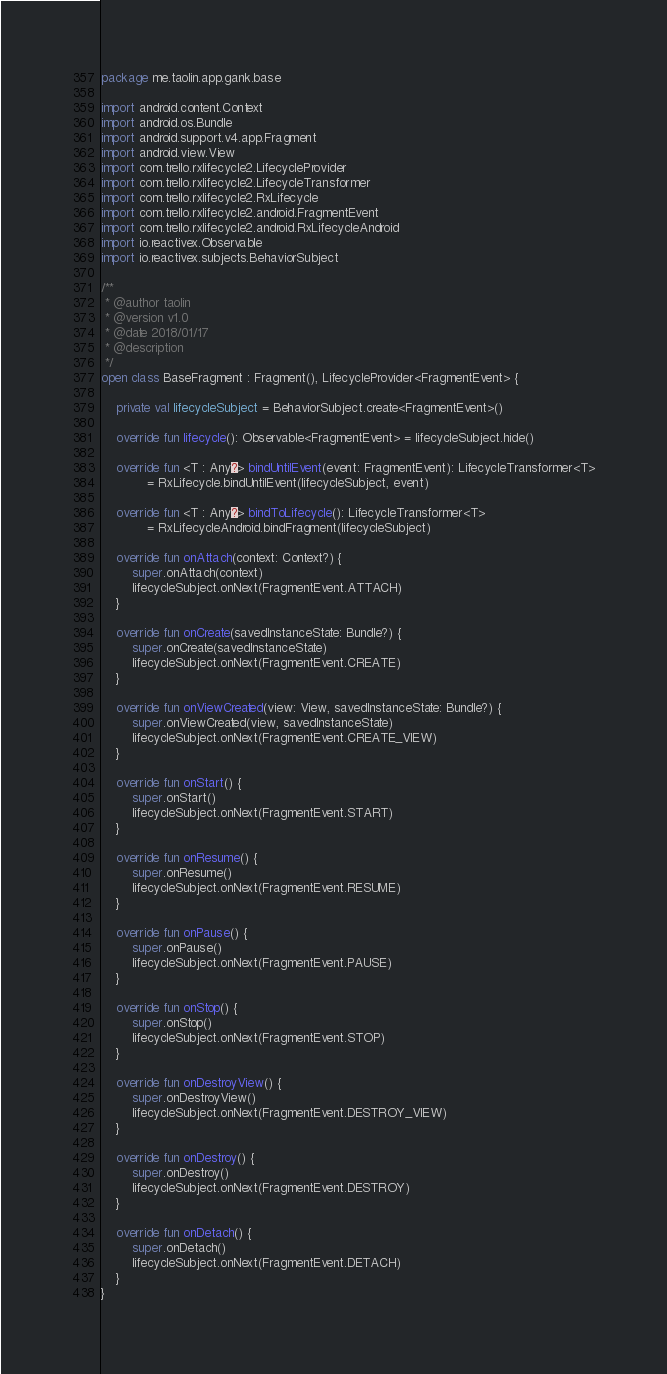Convert code to text. <code><loc_0><loc_0><loc_500><loc_500><_Kotlin_>package me.taolin.app.gank.base

import android.content.Context
import android.os.Bundle
import android.support.v4.app.Fragment
import android.view.View
import com.trello.rxlifecycle2.LifecycleProvider
import com.trello.rxlifecycle2.LifecycleTransformer
import com.trello.rxlifecycle2.RxLifecycle
import com.trello.rxlifecycle2.android.FragmentEvent
import com.trello.rxlifecycle2.android.RxLifecycleAndroid
import io.reactivex.Observable
import io.reactivex.subjects.BehaviorSubject

/**
 * @author taolin
 * @version v1.0
 * @date 2018/01/17
 * @description
 */
open class BaseFragment : Fragment(), LifecycleProvider<FragmentEvent> {

    private val lifecycleSubject = BehaviorSubject.create<FragmentEvent>()

    override fun lifecycle(): Observable<FragmentEvent> = lifecycleSubject.hide()

    override fun <T : Any?> bindUntilEvent(event: FragmentEvent): LifecycleTransformer<T>
            = RxLifecycle.bindUntilEvent(lifecycleSubject, event)

    override fun <T : Any?> bindToLifecycle(): LifecycleTransformer<T>
            = RxLifecycleAndroid.bindFragment(lifecycleSubject)

    override fun onAttach(context: Context?) {
        super.onAttach(context)
        lifecycleSubject.onNext(FragmentEvent.ATTACH)
    }

    override fun onCreate(savedInstanceState: Bundle?) {
        super.onCreate(savedInstanceState)
        lifecycleSubject.onNext(FragmentEvent.CREATE)
    }

    override fun onViewCreated(view: View, savedInstanceState: Bundle?) {
        super.onViewCreated(view, savedInstanceState)
        lifecycleSubject.onNext(FragmentEvent.CREATE_VIEW)
    }

    override fun onStart() {
        super.onStart()
        lifecycleSubject.onNext(FragmentEvent.START)
    }

    override fun onResume() {
        super.onResume()
        lifecycleSubject.onNext(FragmentEvent.RESUME)
    }

    override fun onPause() {
        super.onPause()
        lifecycleSubject.onNext(FragmentEvent.PAUSE)
    }

    override fun onStop() {
        super.onStop()
        lifecycleSubject.onNext(FragmentEvent.STOP)
    }

    override fun onDestroyView() {
        super.onDestroyView()
        lifecycleSubject.onNext(FragmentEvent.DESTROY_VIEW)
    }

    override fun onDestroy() {
        super.onDestroy()
        lifecycleSubject.onNext(FragmentEvent.DESTROY)
    }

    override fun onDetach() {
        super.onDetach()
        lifecycleSubject.onNext(FragmentEvent.DETACH)
    }
}
</code> 